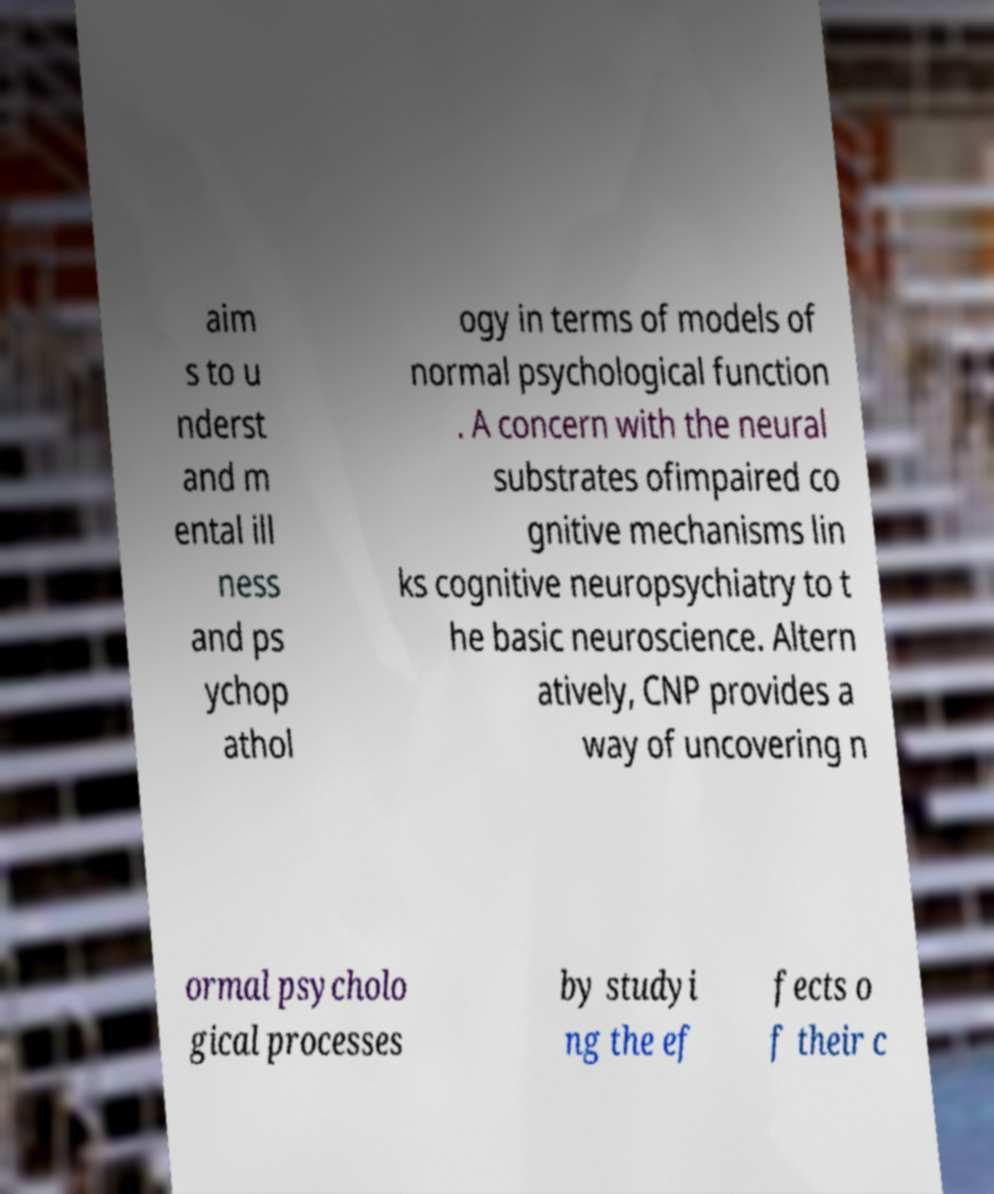Please read and relay the text visible in this image. What does it say? aim s to u nderst and m ental ill ness and ps ychop athol ogy in terms of models of normal psychological function . A concern with the neural substrates ofimpaired co gnitive mechanisms lin ks cognitive neuropsychiatry to t he basic neuroscience. Altern atively, CNP provides a way of uncovering n ormal psycholo gical processes by studyi ng the ef fects o f their c 